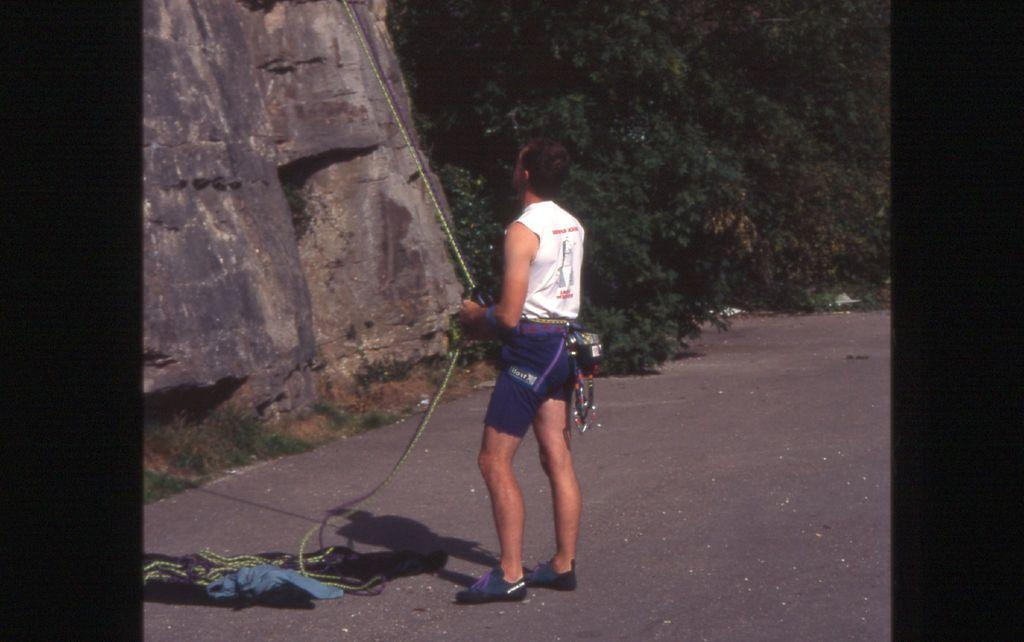Who is the main subject in the image? There is a man in the center of the image. What is the man doing in the image? The man is standing and holding a rope. What can be seen in the background of the image? There are trees and mountains in the background of the image. What is at the bottom of the image? There is a road at the bottom of the image. What is the number of waste bins visible in the image? There are no waste bins visible in the image. What month is it in the image? The image does not provide any information about the month. 